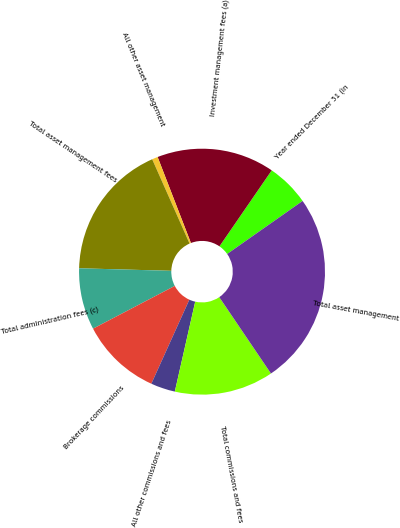Convert chart to OTSL. <chart><loc_0><loc_0><loc_500><loc_500><pie_chart><fcel>Year ended December 31 (in<fcel>Investment management fees (a)<fcel>All other asset management<fcel>Total asset management fees<fcel>Total administration fees (c)<fcel>Brokerage commissions<fcel>All other commissions and fees<fcel>Total commissions and fees<fcel>Total asset management<nl><fcel>5.66%<fcel>15.47%<fcel>0.76%<fcel>17.92%<fcel>8.11%<fcel>10.57%<fcel>3.21%<fcel>13.02%<fcel>25.28%<nl></chart> 